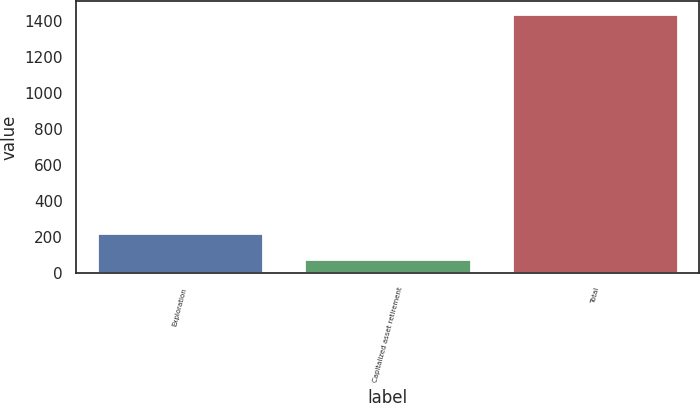Convert chart. <chart><loc_0><loc_0><loc_500><loc_500><bar_chart><fcel>Exploration<fcel>Capitalized asset retirement<fcel>Total<nl><fcel>224<fcel>78<fcel>1435<nl></chart> 